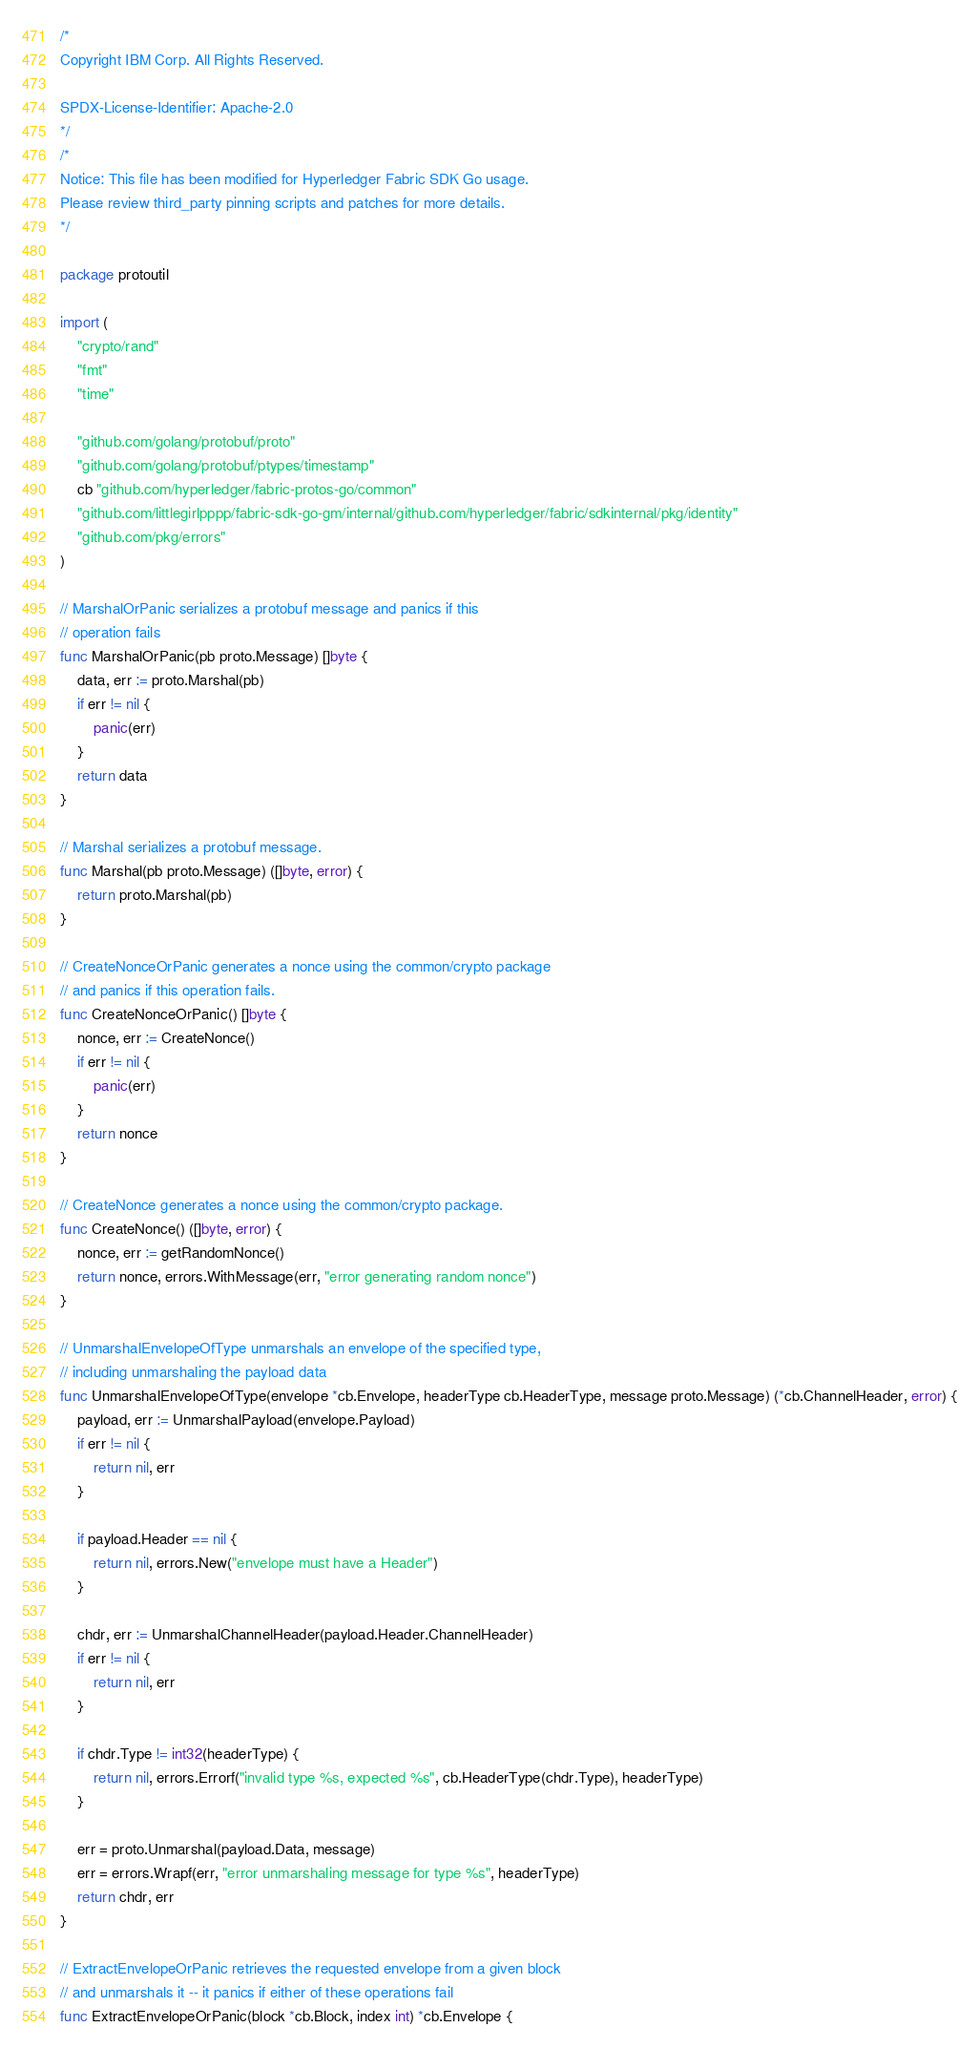<code> <loc_0><loc_0><loc_500><loc_500><_Go_>/*
Copyright IBM Corp. All Rights Reserved.

SPDX-License-Identifier: Apache-2.0
*/
/*
Notice: This file has been modified for Hyperledger Fabric SDK Go usage.
Please review third_party pinning scripts and patches for more details.
*/

package protoutil

import (
	"crypto/rand"
	"fmt"
	"time"

	"github.com/golang/protobuf/proto"
	"github.com/golang/protobuf/ptypes/timestamp"
	cb "github.com/hyperledger/fabric-protos-go/common"
	"github.com/littlegirlpppp/fabric-sdk-go-gm/internal/github.com/hyperledger/fabric/sdkinternal/pkg/identity"
	"github.com/pkg/errors"
)

// MarshalOrPanic serializes a protobuf message and panics if this
// operation fails
func MarshalOrPanic(pb proto.Message) []byte {
	data, err := proto.Marshal(pb)
	if err != nil {
		panic(err)
	}
	return data
}

// Marshal serializes a protobuf message.
func Marshal(pb proto.Message) ([]byte, error) {
	return proto.Marshal(pb)
}

// CreateNonceOrPanic generates a nonce using the common/crypto package
// and panics if this operation fails.
func CreateNonceOrPanic() []byte {
	nonce, err := CreateNonce()
	if err != nil {
		panic(err)
	}
	return nonce
}

// CreateNonce generates a nonce using the common/crypto package.
func CreateNonce() ([]byte, error) {
	nonce, err := getRandomNonce()
	return nonce, errors.WithMessage(err, "error generating random nonce")
}

// UnmarshalEnvelopeOfType unmarshals an envelope of the specified type,
// including unmarshaling the payload data
func UnmarshalEnvelopeOfType(envelope *cb.Envelope, headerType cb.HeaderType, message proto.Message) (*cb.ChannelHeader, error) {
	payload, err := UnmarshalPayload(envelope.Payload)
	if err != nil {
		return nil, err
	}

	if payload.Header == nil {
		return nil, errors.New("envelope must have a Header")
	}

	chdr, err := UnmarshalChannelHeader(payload.Header.ChannelHeader)
	if err != nil {
		return nil, err
	}

	if chdr.Type != int32(headerType) {
		return nil, errors.Errorf("invalid type %s, expected %s", cb.HeaderType(chdr.Type), headerType)
	}

	err = proto.Unmarshal(payload.Data, message)
	err = errors.Wrapf(err, "error unmarshaling message for type %s", headerType)
	return chdr, err
}

// ExtractEnvelopeOrPanic retrieves the requested envelope from a given block
// and unmarshals it -- it panics if either of these operations fail
func ExtractEnvelopeOrPanic(block *cb.Block, index int) *cb.Envelope {</code> 